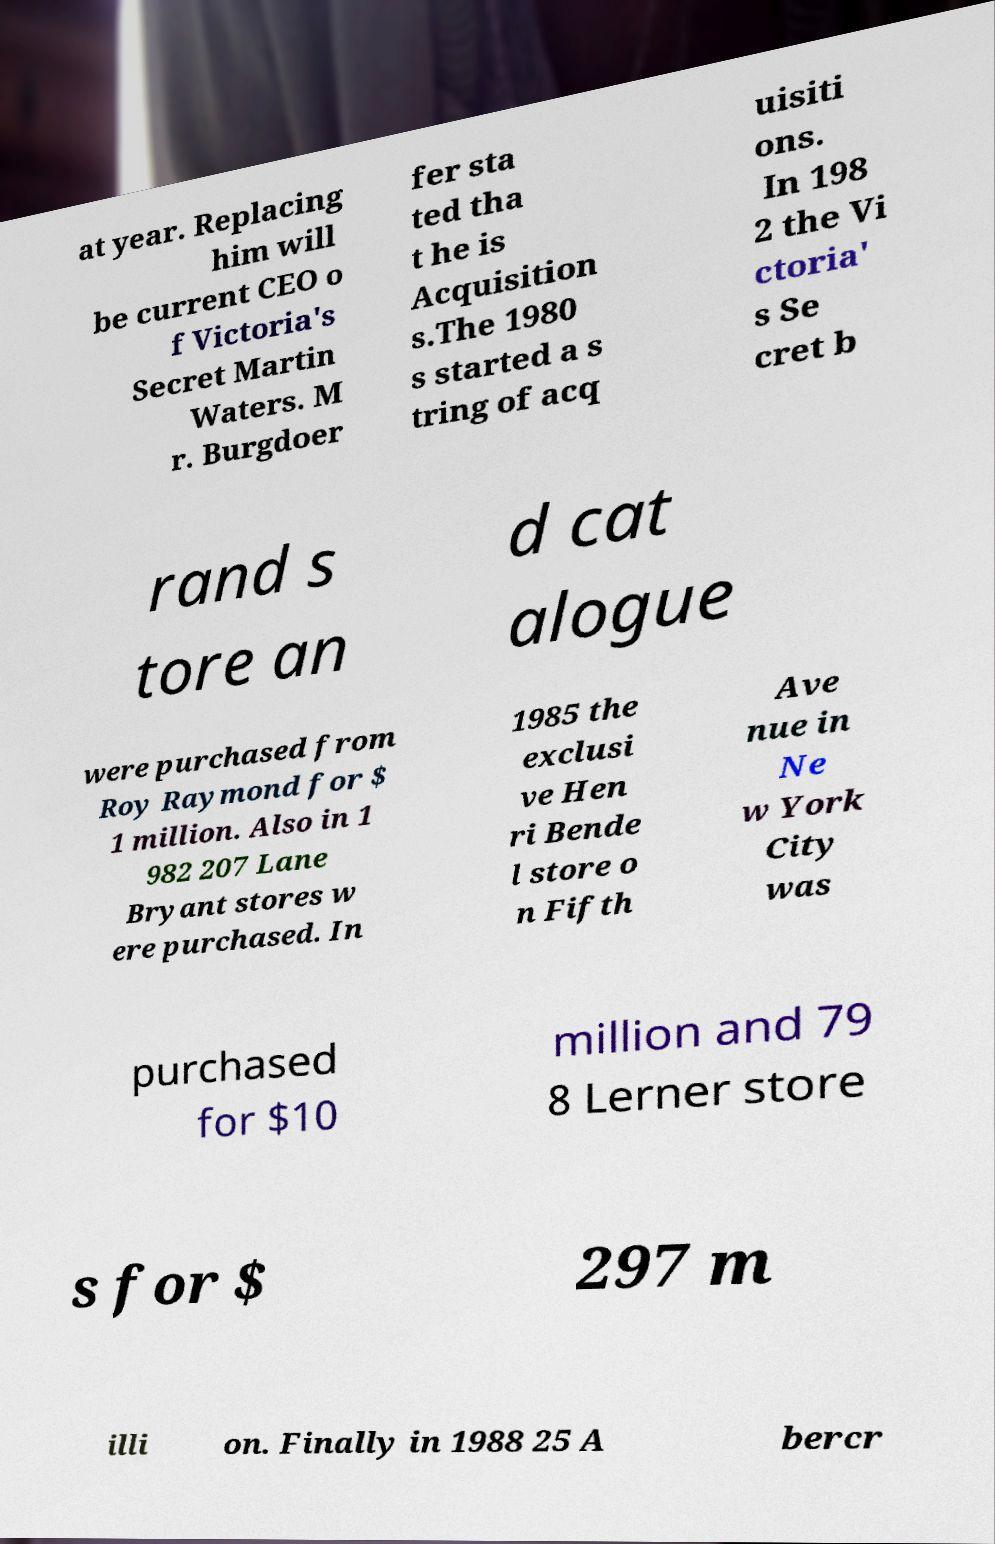Please read and relay the text visible in this image. What does it say? at year. Replacing him will be current CEO o f Victoria's Secret Martin Waters. M r. Burgdoer fer sta ted tha t he is Acquisition s.The 1980 s started a s tring of acq uisiti ons. In 198 2 the Vi ctoria' s Se cret b rand s tore an d cat alogue were purchased from Roy Raymond for $ 1 million. Also in 1 982 207 Lane Bryant stores w ere purchased. In 1985 the exclusi ve Hen ri Bende l store o n Fifth Ave nue in Ne w York City was purchased for $10 million and 79 8 Lerner store s for $ 297 m illi on. Finally in 1988 25 A bercr 